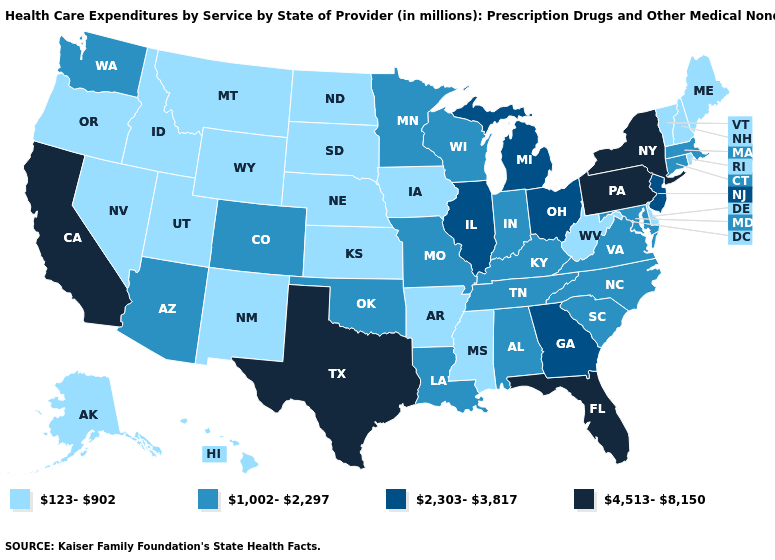Does the first symbol in the legend represent the smallest category?
Keep it brief. Yes. Name the states that have a value in the range 4,513-8,150?
Concise answer only. California, Florida, New York, Pennsylvania, Texas. What is the lowest value in the USA?
Answer briefly. 123-902. Does the map have missing data?
Quick response, please. No. What is the value of Montana?
Keep it brief. 123-902. Among the states that border Louisiana , which have the highest value?
Short answer required. Texas. What is the highest value in states that border Wyoming?
Answer briefly. 1,002-2,297. What is the lowest value in states that border North Carolina?
Quick response, please. 1,002-2,297. What is the lowest value in states that border Montana?
Be succinct. 123-902. Name the states that have a value in the range 123-902?
Give a very brief answer. Alaska, Arkansas, Delaware, Hawaii, Idaho, Iowa, Kansas, Maine, Mississippi, Montana, Nebraska, Nevada, New Hampshire, New Mexico, North Dakota, Oregon, Rhode Island, South Dakota, Utah, Vermont, West Virginia, Wyoming. What is the lowest value in the West?
Write a very short answer. 123-902. What is the highest value in states that border California?
Give a very brief answer. 1,002-2,297. How many symbols are there in the legend?
Quick response, please. 4. Which states hav the highest value in the West?
Quick response, please. California. 